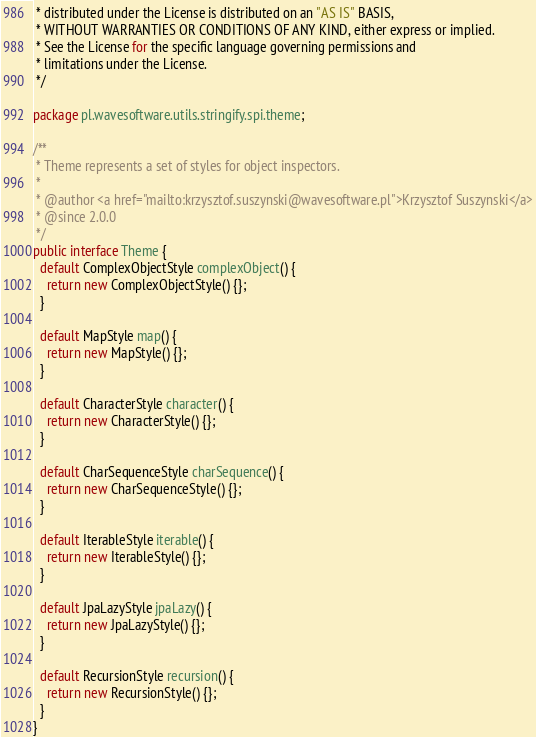<code> <loc_0><loc_0><loc_500><loc_500><_Java_> * distributed under the License is distributed on an "AS IS" BASIS,
 * WITHOUT WARRANTIES OR CONDITIONS OF ANY KIND, either express or implied.
 * See the License for the specific language governing permissions and
 * limitations under the License.
 */

package pl.wavesoftware.utils.stringify.spi.theme;

/**
 * Theme represents a set of styles for object inspectors.
 *
 * @author <a href="mailto:krzysztof.suszynski@wavesoftware.pl">Krzysztof Suszynski</a>
 * @since 2.0.0
 */
public interface Theme {
  default ComplexObjectStyle complexObject() {
    return new ComplexObjectStyle() {};
  }

  default MapStyle map() {
    return new MapStyle() {};
  }

  default CharacterStyle character() {
    return new CharacterStyle() {};
  }

  default CharSequenceStyle charSequence() {
    return new CharSequenceStyle() {};
  }

  default IterableStyle iterable() {
    return new IterableStyle() {};
  }

  default JpaLazyStyle jpaLazy() {
    return new JpaLazyStyle() {};
  }

  default RecursionStyle recursion() {
    return new RecursionStyle() {};
  }
}
</code> 